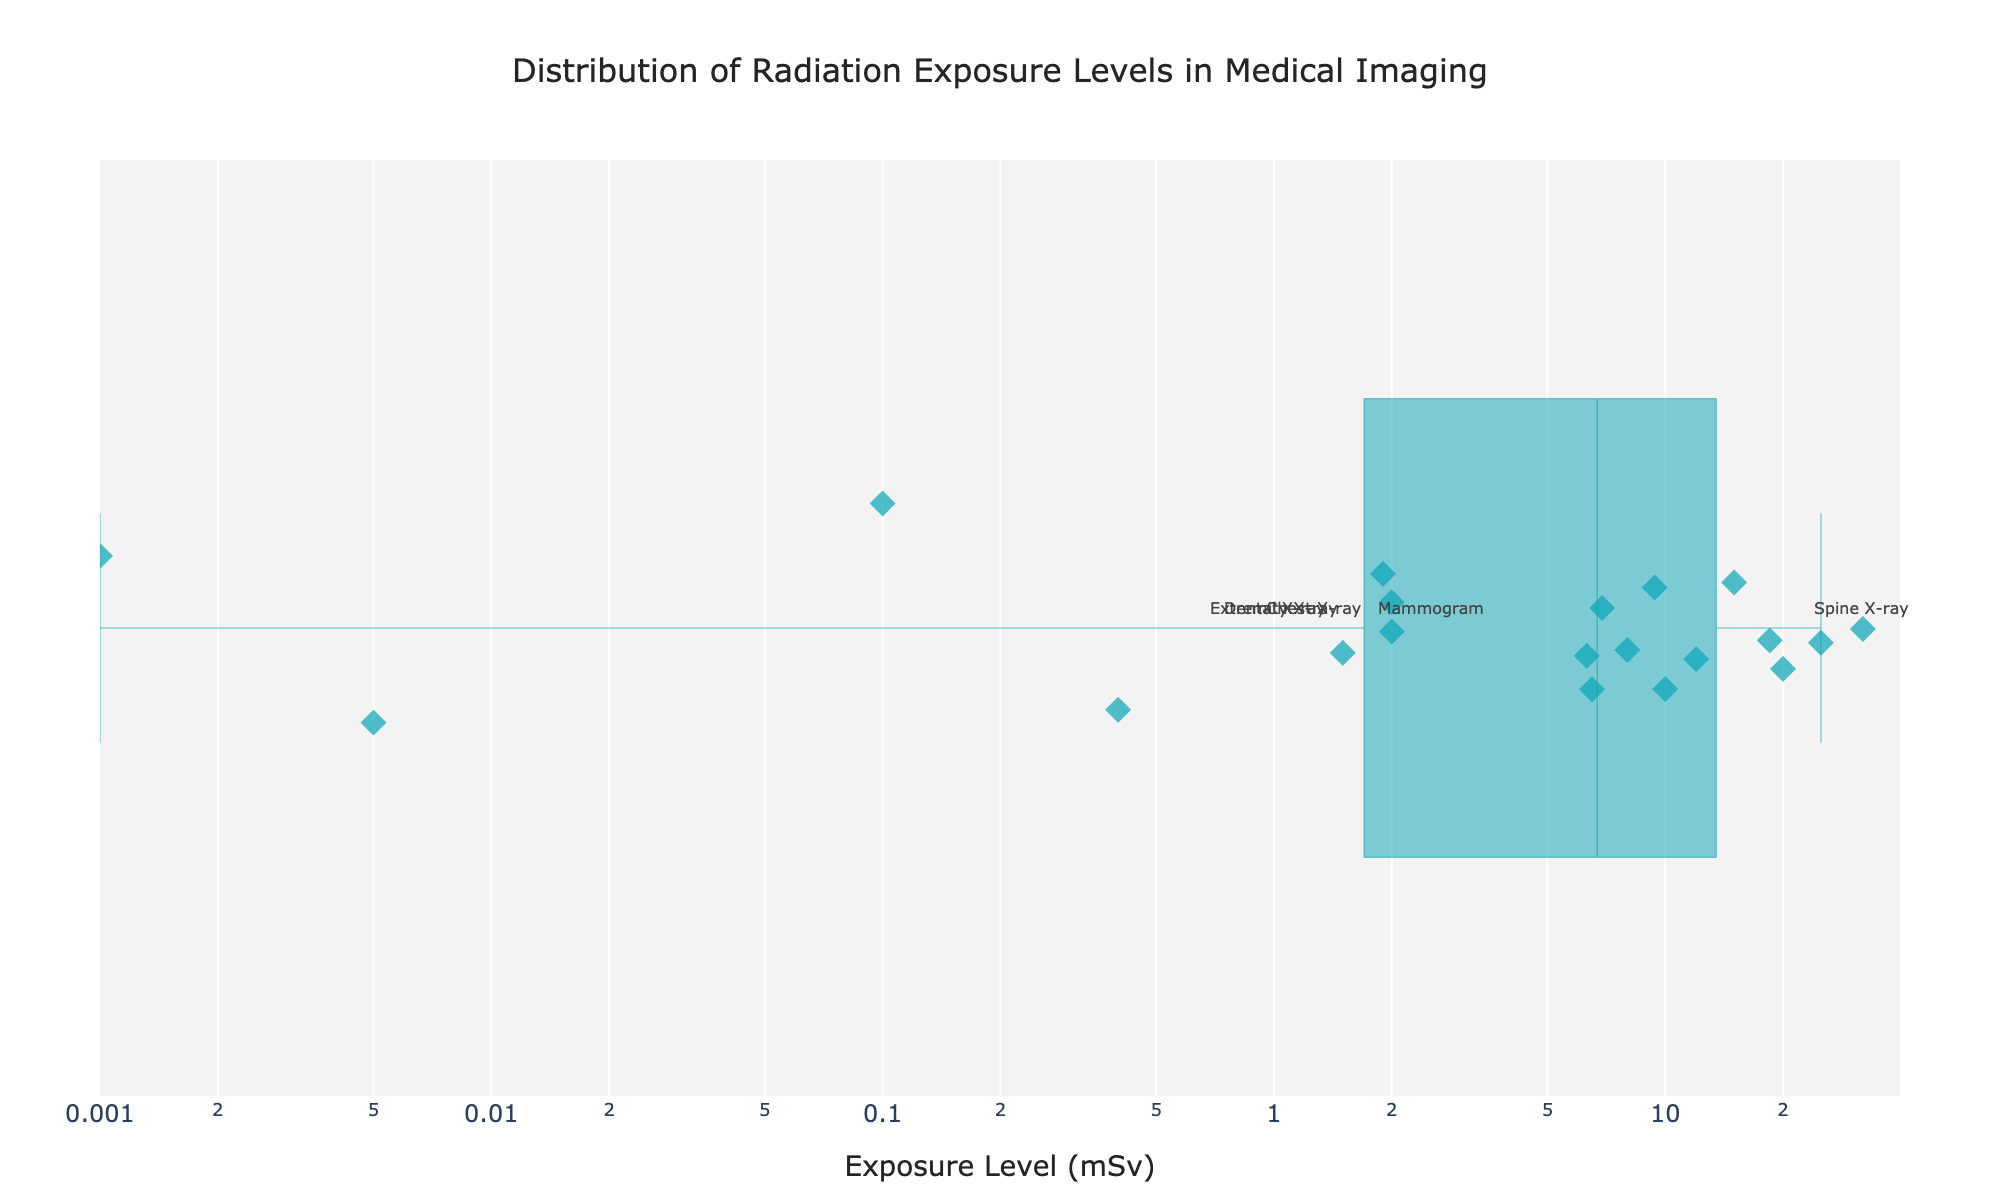What is the title of the strip plot? The title of a plot is usually displayed at the top and summarizes what the plot is about. In this case, the title is placed centrally and provides a clear description.
Answer: Distribution of Radiation Exposure Levels in Medical Imaging What is the range of the radiation exposure levels shown on the x-axis? By observing the scale provided on the x-axis, we can note the minimum and maximum values. Here, a logarithmic scale is used which shows a range from approximately 0.001 to 40 mSv.
Answer: 0.001 to 40 mSv Which medical procedure has the highest radiation exposure level? Looking at the furthest data point to the right on the x-axis and reading the label associated with it, we can determine the procedure with the highest exposure level. Here, it is labeled at 32.0 mSv.
Answer: Whole Body PET/CT What is the median radiation exposure level among the procedures? To find the median, we need to locate the middle value in the sorted list of exposure levels. As there are 20 procedures, the median will be the average of the 10th and 11th values in the sorted list. Observing the plot, these values (6.3 and 6.5 mSv) can be identified.
Answer: (6.3 + 6.5) / 2 = 6.4 mSv Which procedure has a radiation exposure level closest to 10 mSv? By locating the data point that is closest to 10 mSv along the x-axis and checking its label, we can identify the procedure. The closest value is precisely labeled at 10.0 mSv.
Answer: CT Scan (Abdomen) Which two procedures occupy the smallest exposure levels on the plot and how do their levels compare? The two points at the leftmost side of the x-axis represent the smallest exposure levels. Finding and labeling these values, we see they are around 0.001 mSv and 0.005 mSv.
Answer: Extremity X-ray (0.001 mSv) and Dental X-ray (0.005 mSv); Extremity X-ray < Dental X-ray How does the radiation exposure of a PET Scan compare to that of an Angiography? By identifying the points for both PET Scan and Angiography, we compare their x-axis positions. PET Scan (25.0 mSv) is to the left of Angiography (12.0 mSv).
Answer: PET Scan > Angiography Which procedures have exposure levels greater than 20 mSv? By identifying all points to the right of the 20 mSv mark on the x-axis, we can determine which procedures they correspond to, labeled accordingly.
Answer: Whole Body PET/CT (32.0 mSv) and Gallium Scan (18.5 mSv) What type of scan has an exposure level of 2.0 mSv and how is it depicted? By locating the data point exactly at 2.0 mSv on the x-axis, the associated label shows the procedure. Observing the color and marker details in the legend helps confirm this identification.
Answer: CT Scan (Head); depicted with a diamond marker (go.Box) 